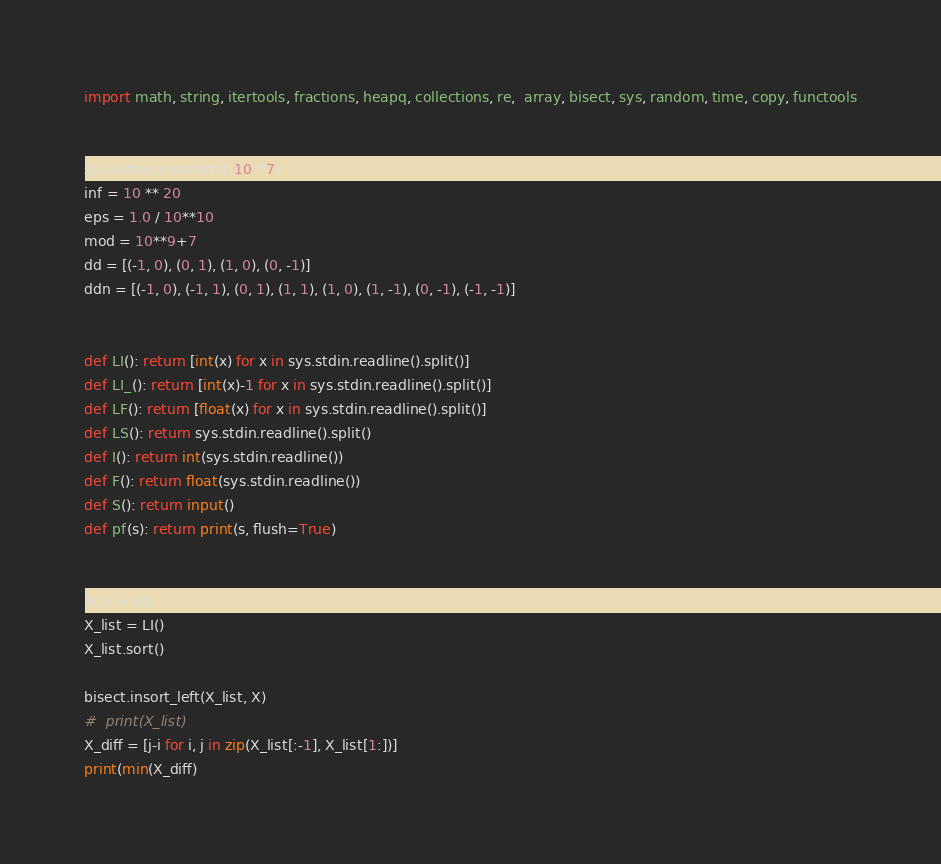Convert code to text. <code><loc_0><loc_0><loc_500><loc_500><_Python_>import math, string, itertools, fractions, heapq, collections, re,  array, bisect, sys, random, time, copy, functools


sys.setrecursionlimit(10**7)
inf = 10 ** 20
eps = 1.0 / 10**10
mod = 10**9+7
dd = [(-1, 0), (0, 1), (1, 0), (0, -1)]
ddn = [(-1, 0), (-1, 1), (0, 1), (1, 1), (1, 0), (1, -1), (0, -1), (-1, -1)]


def LI(): return [int(x) for x in sys.stdin.readline().split()]
def LI_(): return [int(x)-1 for x in sys.stdin.readline().split()]
def LF(): return [float(x) for x in sys.stdin.readline().split()]
def LS(): return sys.stdin.readline().split()
def I(): return int(sys.stdin.readline())
def F(): return float(sys.stdin.readline())
def S(): return input()
def pf(s): return print(s, flush=True)


N, X = LI()
X_list = LI()
X_list.sort()

bisect.insort_left(X_list, X)
#  print(X_list)
X_diff = [j-i for i, j in zip(X_list[:-1], X_list[1:])]
print(min(X_diff)
</code> 